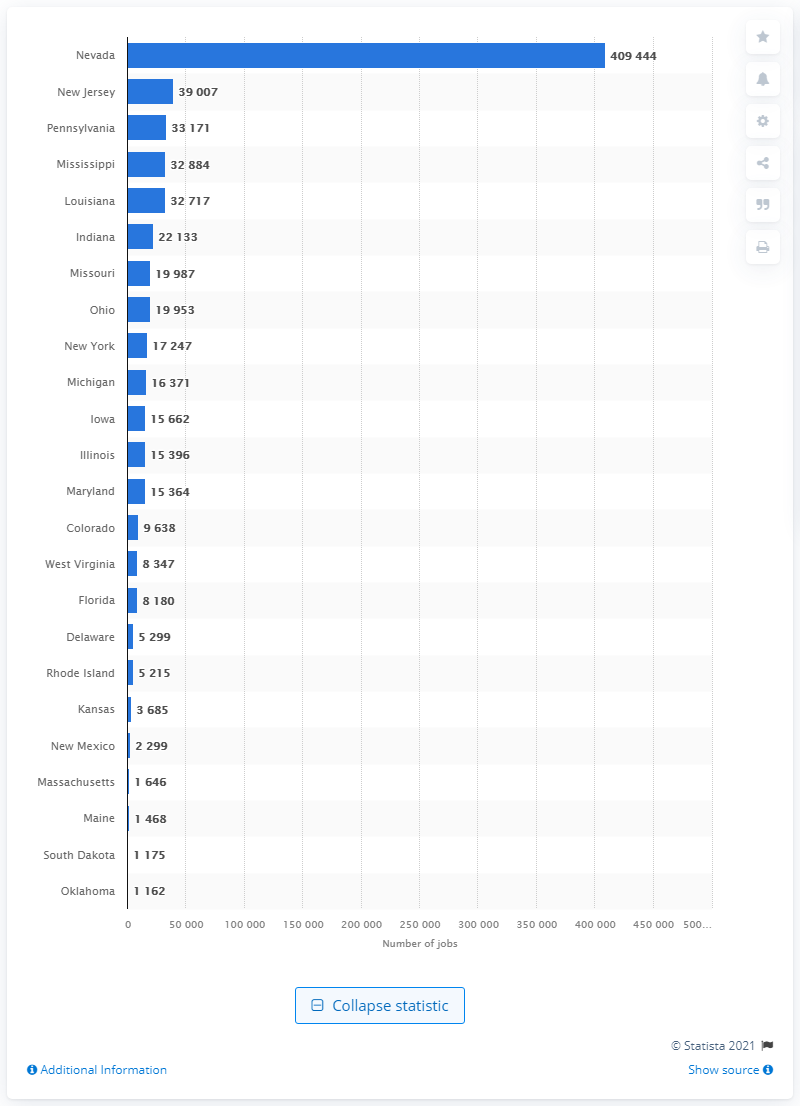List a handful of essential elements in this visual. In 2018, a total of 22,133 employees were working in commercial casinos in the state of Indiana. 